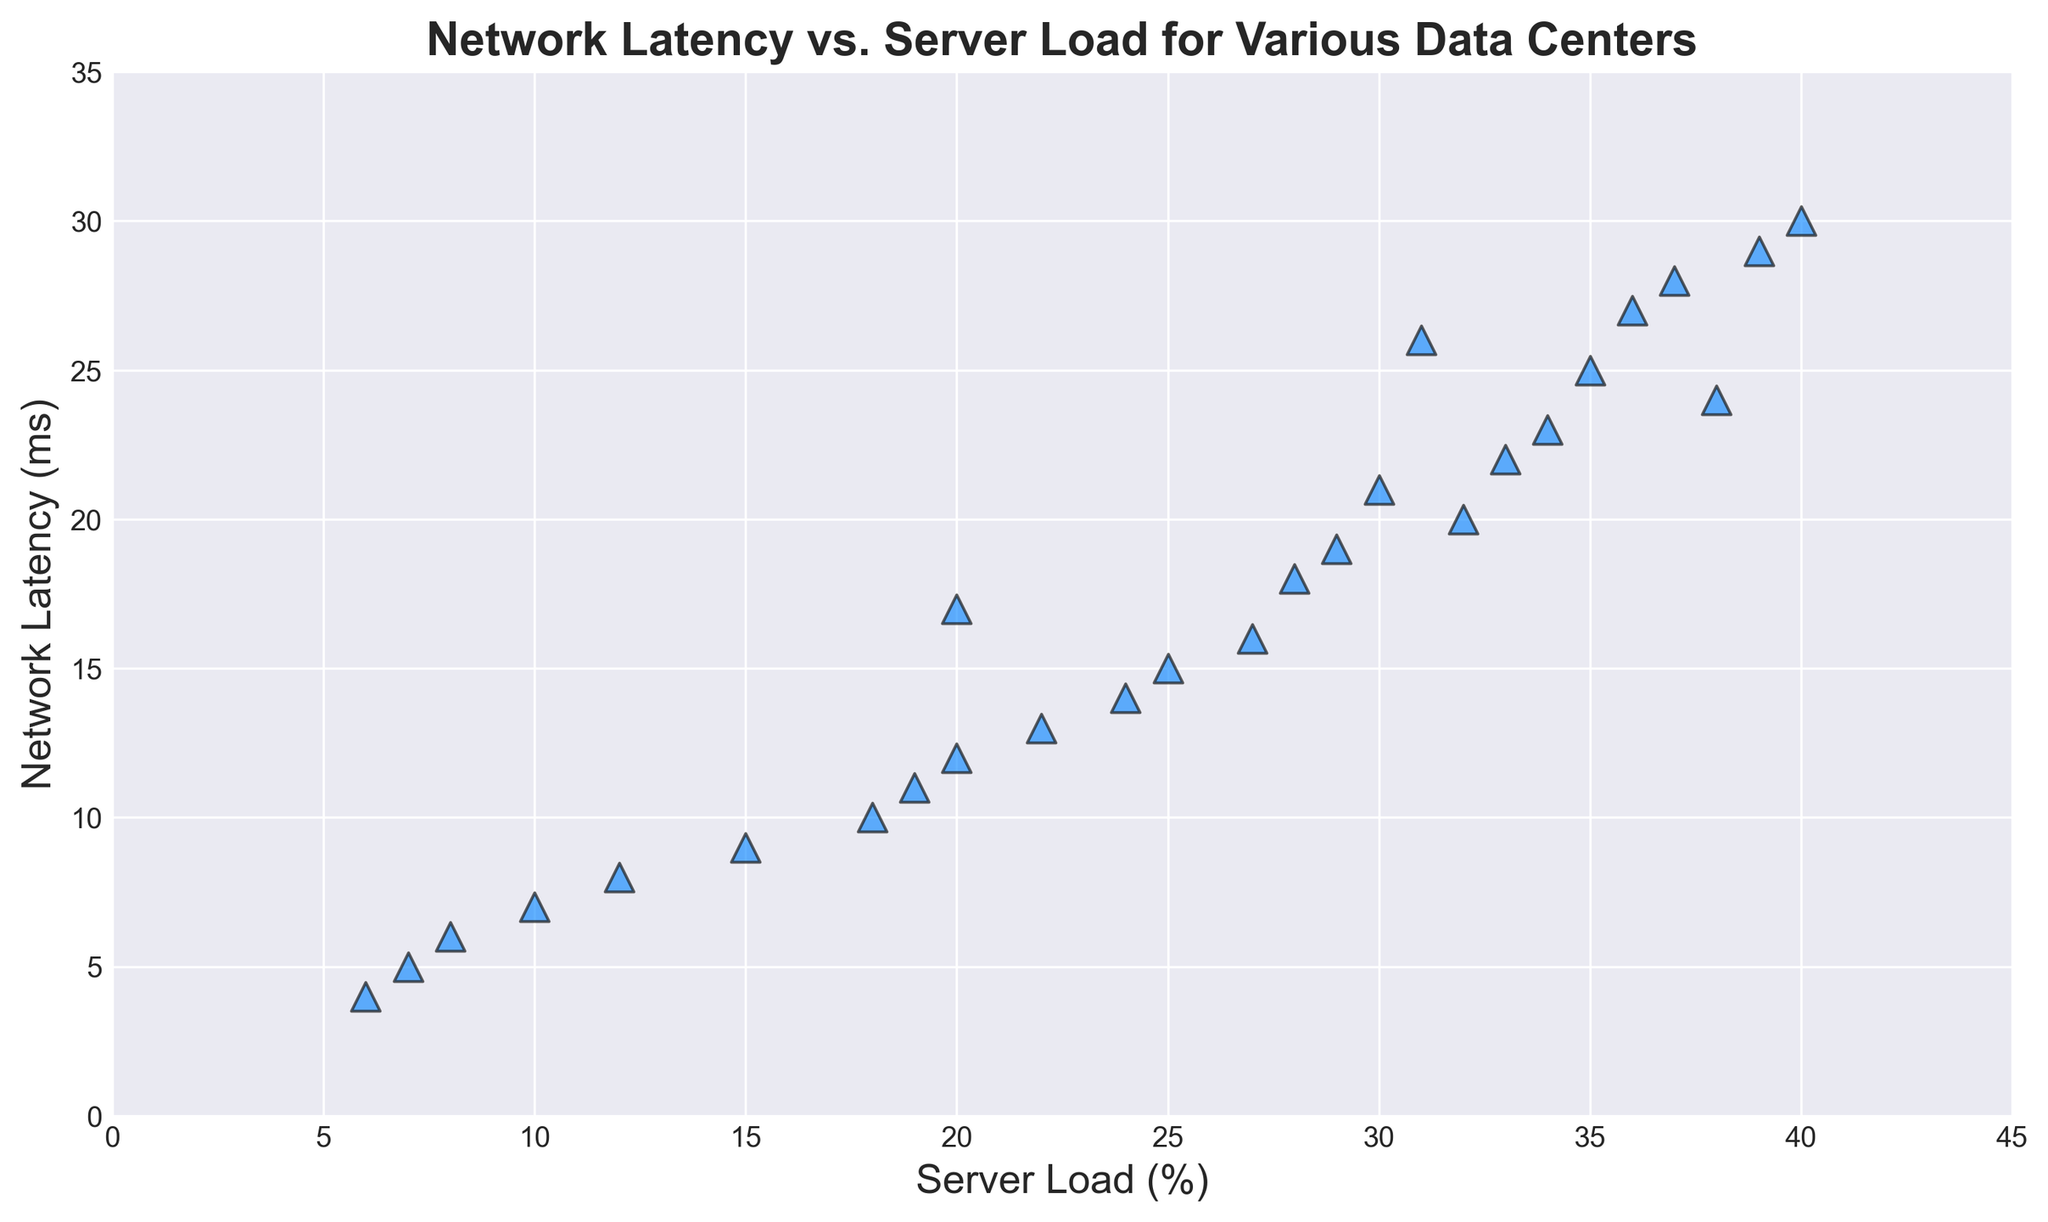What's the highest Server Load (%) recorded in the data? By observing the x-axis for the maximum value of Server Load (%), we see the highest Server Load recorded is at 40%.
Answer: 40% What is the general trend between Network Latency and Server Load? By looking at the scatter plot, we see that as the Server Load increases, the Network Latency also tends to increase, indicating a positive correlation.
Answer: Positive correlation What is the Network Latency when the Server Load is 20%? Check the x-axis value for 20% Server Load and find the corresponding y-axis value for Network Latency, which falls at 12 ms.
Answer: 12 ms Are there any outliers in terms of Network Latency for a given Server Load? Look for any data points that significantly deviate from the general trend. We see a point where Network Latency is 30 ms while Server Load is 30%, which might be considered an outlier.
Answer: Yes When the Server Load is below 10%, what is the range of Network Latency observed? Filter the data points with Server Load below 10% and observe their corresponding Network Latency values. The range is from 4 ms to 10 ms.
Answer: 4 ms to 10 ms Which data center has the lowest Network Latency and what is its Server Load percentage? Identify the point with the lowest y-axis value and note the corresponding x-axis value. The lowest Network Latency is 4 ms with a Server Load of 6%.
Answer: 4 ms with 6% How many data points have Network Latency above 25 ms? Count the number of points that fall above the 25 ms mark on the y-axis. There are 5 points above this threshold.
Answer: 5 How often does a doubling of Server Load result in a significant increase in Network Latency? Compare pairs of data points (e.g., 10% to 20%, 15% to 30%) and observe the corresponding increase in Network Latency. Doubling often causes a noticeable increase in Latency.
Answer: Often Is there a data point where both Server Load and Network Latency are multiples of 5? Look for points where both the x-axis (Server Load) and y-axis (Network Latency) values are multiples of 5. An example is Server Load of 25% and Network Latency of 15 ms.
Answer: Yes (25%, 15 ms) What is the average Network Latency for Server Loads between 15% and 25%? Identify the data points within the 15%-25% range, sum their Network Latency values, and divide by the number of data points. Average Network Latency for this range is approximately 16.5 ms.
Answer: 16.5 ms 